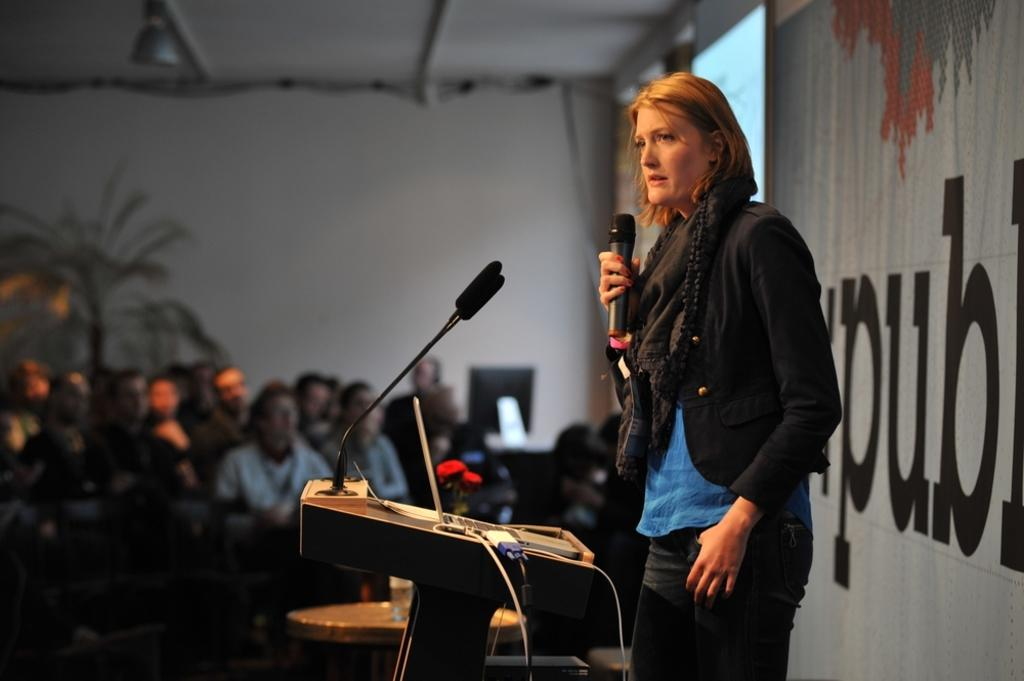What are the people in the image doing? The people in the image are sitting. What is the woman at the podium doing? The woman is standing at a podium and holding a microphone in her hand. What might the woman be doing with the microphone? The woman might be using the microphone to amplify her voice while speaking to the people. What are the people doing in response to the woman? The people are listening to the woman. What type of stretch is the woman performing at the podium? There is no stretch being performed by the woman at the podium in the image. 